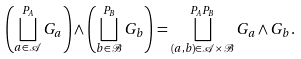<formula> <loc_0><loc_0><loc_500><loc_500>\left ( \bigsqcup _ { a \in \mathcal { A } } ^ { P _ { A } } G _ { a } \right ) \wedge \left ( \bigsqcup _ { b \in \mathcal { B } } ^ { P _ { B } } G _ { b } \right ) = \bigsqcup _ { ( a , b ) \in \mathcal { A } \times \mathcal { B } } ^ { P _ { A } P _ { B } } G _ { a } \wedge G _ { b } .</formula> 